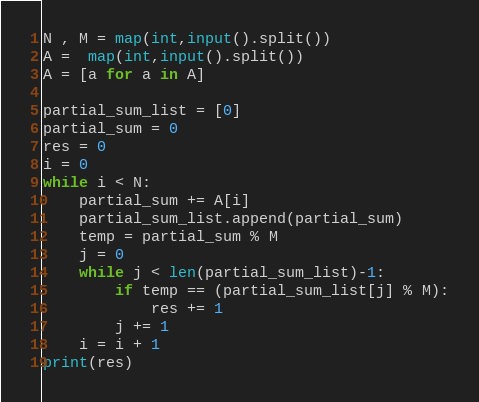<code> <loc_0><loc_0><loc_500><loc_500><_Python_>N , M = map(int,input().split())
A =  map(int,input().split())
A = [a for a in A]

partial_sum_list = [0]
partial_sum = 0
res = 0
i = 0
while i < N:
    partial_sum += A[i]
    partial_sum_list.append(partial_sum)
    temp = partial_sum % M
    j = 0
    while j < len(partial_sum_list)-1:
        if temp == (partial_sum_list[j] % M):
            res += 1
        j += 1
    i = i + 1
print(res)</code> 